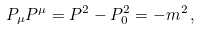Convert formula to latex. <formula><loc_0><loc_0><loc_500><loc_500>P _ { \mu } P ^ { \mu } = { P } ^ { 2 } - P _ { 0 } ^ { 2 } = - m ^ { 2 } \, ,</formula> 